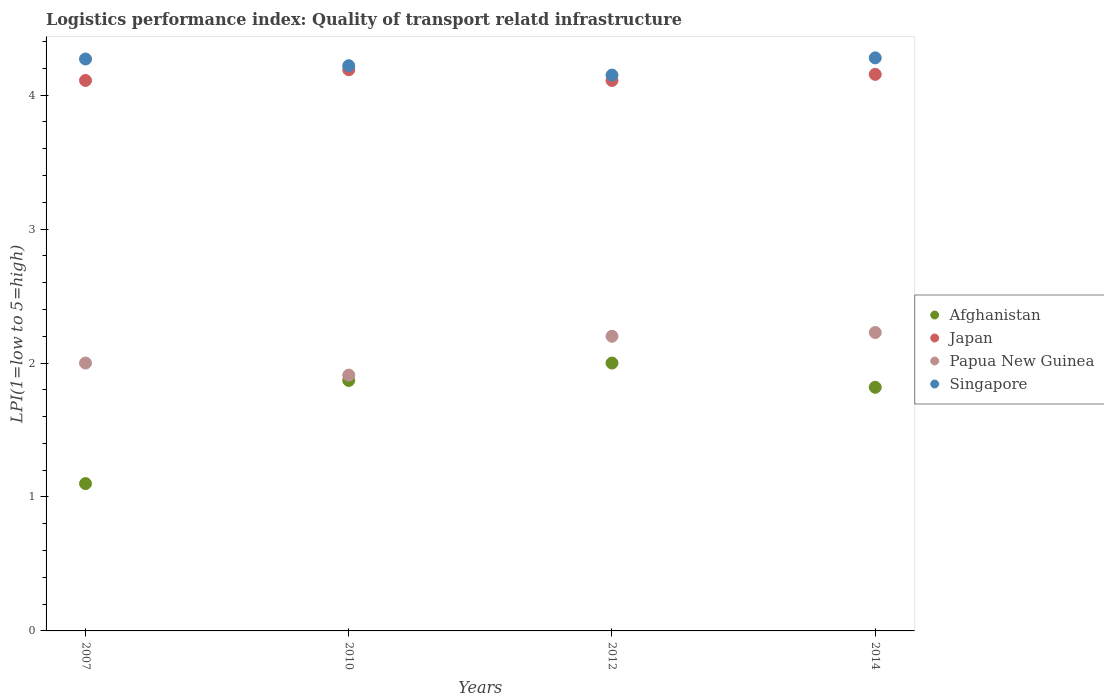How many different coloured dotlines are there?
Provide a short and direct response. 4. Is the number of dotlines equal to the number of legend labels?
Provide a succinct answer. Yes. What is the logistics performance index in Afghanistan in 2010?
Keep it short and to the point. 1.87. In which year was the logistics performance index in Papua New Guinea minimum?
Give a very brief answer. 2010. What is the total logistics performance index in Papua New Guinea in the graph?
Provide a short and direct response. 8.34. What is the difference between the logistics performance index in Papua New Guinea in 2010 and that in 2012?
Your response must be concise. -0.29. What is the difference between the logistics performance index in Singapore in 2007 and the logistics performance index in Afghanistan in 2010?
Offer a terse response. 2.4. What is the average logistics performance index in Afghanistan per year?
Give a very brief answer. 1.7. In the year 2012, what is the difference between the logistics performance index in Singapore and logistics performance index in Afghanistan?
Offer a terse response. 2.15. What is the ratio of the logistics performance index in Papua New Guinea in 2007 to that in 2014?
Keep it short and to the point. 0.9. Is the logistics performance index in Papua New Guinea in 2007 less than that in 2014?
Keep it short and to the point. Yes. Is the difference between the logistics performance index in Singapore in 2007 and 2012 greater than the difference between the logistics performance index in Afghanistan in 2007 and 2012?
Ensure brevity in your answer.  Yes. What is the difference between the highest and the second highest logistics performance index in Papua New Guinea?
Make the answer very short. 0.03. What is the difference between the highest and the lowest logistics performance index in Singapore?
Make the answer very short. 0.13. Is the sum of the logistics performance index in Singapore in 2010 and 2012 greater than the maximum logistics performance index in Afghanistan across all years?
Provide a succinct answer. Yes. Is it the case that in every year, the sum of the logistics performance index in Japan and logistics performance index in Singapore  is greater than the logistics performance index in Papua New Guinea?
Ensure brevity in your answer.  Yes. Is the logistics performance index in Afghanistan strictly greater than the logistics performance index in Singapore over the years?
Provide a short and direct response. No. Is the logistics performance index in Papua New Guinea strictly less than the logistics performance index in Japan over the years?
Give a very brief answer. Yes. How many dotlines are there?
Offer a very short reply. 4. How many years are there in the graph?
Make the answer very short. 4. What is the difference between two consecutive major ticks on the Y-axis?
Provide a short and direct response. 1. Does the graph contain grids?
Provide a short and direct response. No. What is the title of the graph?
Give a very brief answer. Logistics performance index: Quality of transport relatd infrastructure. Does "Montenegro" appear as one of the legend labels in the graph?
Offer a terse response. No. What is the label or title of the X-axis?
Your response must be concise. Years. What is the label or title of the Y-axis?
Ensure brevity in your answer.  LPI(1=low to 5=high). What is the LPI(1=low to 5=high) of Afghanistan in 2007?
Offer a very short reply. 1.1. What is the LPI(1=low to 5=high) in Japan in 2007?
Make the answer very short. 4.11. What is the LPI(1=low to 5=high) in Papua New Guinea in 2007?
Offer a very short reply. 2. What is the LPI(1=low to 5=high) in Singapore in 2007?
Keep it short and to the point. 4.27. What is the LPI(1=low to 5=high) in Afghanistan in 2010?
Ensure brevity in your answer.  1.87. What is the LPI(1=low to 5=high) in Japan in 2010?
Keep it short and to the point. 4.19. What is the LPI(1=low to 5=high) in Papua New Guinea in 2010?
Your response must be concise. 1.91. What is the LPI(1=low to 5=high) of Singapore in 2010?
Ensure brevity in your answer.  4.22. What is the LPI(1=low to 5=high) in Afghanistan in 2012?
Offer a terse response. 2. What is the LPI(1=low to 5=high) of Japan in 2012?
Offer a very short reply. 4.11. What is the LPI(1=low to 5=high) of Papua New Guinea in 2012?
Your answer should be compact. 2.2. What is the LPI(1=low to 5=high) in Singapore in 2012?
Your response must be concise. 4.15. What is the LPI(1=low to 5=high) of Afghanistan in 2014?
Provide a succinct answer. 1.82. What is the LPI(1=low to 5=high) of Japan in 2014?
Offer a terse response. 4.16. What is the LPI(1=low to 5=high) in Papua New Guinea in 2014?
Give a very brief answer. 2.23. What is the LPI(1=low to 5=high) of Singapore in 2014?
Your response must be concise. 4.28. Across all years, what is the maximum LPI(1=low to 5=high) of Afghanistan?
Keep it short and to the point. 2. Across all years, what is the maximum LPI(1=low to 5=high) of Japan?
Provide a short and direct response. 4.19. Across all years, what is the maximum LPI(1=low to 5=high) of Papua New Guinea?
Give a very brief answer. 2.23. Across all years, what is the maximum LPI(1=low to 5=high) of Singapore?
Keep it short and to the point. 4.28. Across all years, what is the minimum LPI(1=low to 5=high) in Japan?
Your answer should be very brief. 4.11. Across all years, what is the minimum LPI(1=low to 5=high) of Papua New Guinea?
Your answer should be compact. 1.91. Across all years, what is the minimum LPI(1=low to 5=high) in Singapore?
Make the answer very short. 4.15. What is the total LPI(1=low to 5=high) in Afghanistan in the graph?
Ensure brevity in your answer.  6.79. What is the total LPI(1=low to 5=high) in Japan in the graph?
Provide a short and direct response. 16.57. What is the total LPI(1=low to 5=high) of Papua New Guinea in the graph?
Keep it short and to the point. 8.34. What is the total LPI(1=low to 5=high) of Singapore in the graph?
Your answer should be compact. 16.92. What is the difference between the LPI(1=low to 5=high) in Afghanistan in 2007 and that in 2010?
Offer a terse response. -0.77. What is the difference between the LPI(1=low to 5=high) of Japan in 2007 and that in 2010?
Your answer should be very brief. -0.08. What is the difference between the LPI(1=low to 5=high) in Papua New Guinea in 2007 and that in 2010?
Your answer should be compact. 0.09. What is the difference between the LPI(1=low to 5=high) in Singapore in 2007 and that in 2010?
Your answer should be very brief. 0.05. What is the difference between the LPI(1=low to 5=high) of Afghanistan in 2007 and that in 2012?
Keep it short and to the point. -0.9. What is the difference between the LPI(1=low to 5=high) of Japan in 2007 and that in 2012?
Provide a short and direct response. 0. What is the difference between the LPI(1=low to 5=high) of Singapore in 2007 and that in 2012?
Offer a very short reply. 0.12. What is the difference between the LPI(1=low to 5=high) in Afghanistan in 2007 and that in 2014?
Keep it short and to the point. -0.72. What is the difference between the LPI(1=low to 5=high) of Japan in 2007 and that in 2014?
Make the answer very short. -0.05. What is the difference between the LPI(1=low to 5=high) in Papua New Guinea in 2007 and that in 2014?
Provide a succinct answer. -0.23. What is the difference between the LPI(1=low to 5=high) of Singapore in 2007 and that in 2014?
Ensure brevity in your answer.  -0.01. What is the difference between the LPI(1=low to 5=high) of Afghanistan in 2010 and that in 2012?
Give a very brief answer. -0.13. What is the difference between the LPI(1=low to 5=high) of Papua New Guinea in 2010 and that in 2012?
Your answer should be compact. -0.29. What is the difference between the LPI(1=low to 5=high) of Singapore in 2010 and that in 2012?
Keep it short and to the point. 0.07. What is the difference between the LPI(1=low to 5=high) of Afghanistan in 2010 and that in 2014?
Your response must be concise. 0.05. What is the difference between the LPI(1=low to 5=high) in Japan in 2010 and that in 2014?
Your answer should be very brief. 0.03. What is the difference between the LPI(1=low to 5=high) in Papua New Guinea in 2010 and that in 2014?
Keep it short and to the point. -0.32. What is the difference between the LPI(1=low to 5=high) of Singapore in 2010 and that in 2014?
Offer a very short reply. -0.06. What is the difference between the LPI(1=low to 5=high) of Afghanistan in 2012 and that in 2014?
Your answer should be very brief. 0.18. What is the difference between the LPI(1=low to 5=high) of Japan in 2012 and that in 2014?
Keep it short and to the point. -0.05. What is the difference between the LPI(1=low to 5=high) in Papua New Guinea in 2012 and that in 2014?
Provide a short and direct response. -0.03. What is the difference between the LPI(1=low to 5=high) in Singapore in 2012 and that in 2014?
Give a very brief answer. -0.13. What is the difference between the LPI(1=low to 5=high) of Afghanistan in 2007 and the LPI(1=low to 5=high) of Japan in 2010?
Offer a very short reply. -3.09. What is the difference between the LPI(1=low to 5=high) of Afghanistan in 2007 and the LPI(1=low to 5=high) of Papua New Guinea in 2010?
Provide a succinct answer. -0.81. What is the difference between the LPI(1=low to 5=high) in Afghanistan in 2007 and the LPI(1=low to 5=high) in Singapore in 2010?
Ensure brevity in your answer.  -3.12. What is the difference between the LPI(1=low to 5=high) of Japan in 2007 and the LPI(1=low to 5=high) of Papua New Guinea in 2010?
Your answer should be very brief. 2.2. What is the difference between the LPI(1=low to 5=high) of Japan in 2007 and the LPI(1=low to 5=high) of Singapore in 2010?
Your response must be concise. -0.11. What is the difference between the LPI(1=low to 5=high) in Papua New Guinea in 2007 and the LPI(1=low to 5=high) in Singapore in 2010?
Your response must be concise. -2.22. What is the difference between the LPI(1=low to 5=high) of Afghanistan in 2007 and the LPI(1=low to 5=high) of Japan in 2012?
Provide a succinct answer. -3.01. What is the difference between the LPI(1=low to 5=high) of Afghanistan in 2007 and the LPI(1=low to 5=high) of Singapore in 2012?
Keep it short and to the point. -3.05. What is the difference between the LPI(1=low to 5=high) in Japan in 2007 and the LPI(1=low to 5=high) in Papua New Guinea in 2012?
Offer a very short reply. 1.91. What is the difference between the LPI(1=low to 5=high) of Japan in 2007 and the LPI(1=low to 5=high) of Singapore in 2012?
Your response must be concise. -0.04. What is the difference between the LPI(1=low to 5=high) of Papua New Guinea in 2007 and the LPI(1=low to 5=high) of Singapore in 2012?
Ensure brevity in your answer.  -2.15. What is the difference between the LPI(1=low to 5=high) of Afghanistan in 2007 and the LPI(1=low to 5=high) of Japan in 2014?
Your answer should be compact. -3.06. What is the difference between the LPI(1=low to 5=high) in Afghanistan in 2007 and the LPI(1=low to 5=high) in Papua New Guinea in 2014?
Provide a succinct answer. -1.13. What is the difference between the LPI(1=low to 5=high) of Afghanistan in 2007 and the LPI(1=low to 5=high) of Singapore in 2014?
Provide a short and direct response. -3.18. What is the difference between the LPI(1=low to 5=high) of Japan in 2007 and the LPI(1=low to 5=high) of Papua New Guinea in 2014?
Your response must be concise. 1.88. What is the difference between the LPI(1=low to 5=high) in Japan in 2007 and the LPI(1=low to 5=high) in Singapore in 2014?
Make the answer very short. -0.17. What is the difference between the LPI(1=low to 5=high) in Papua New Guinea in 2007 and the LPI(1=low to 5=high) in Singapore in 2014?
Your answer should be compact. -2.28. What is the difference between the LPI(1=low to 5=high) of Afghanistan in 2010 and the LPI(1=low to 5=high) of Japan in 2012?
Ensure brevity in your answer.  -2.24. What is the difference between the LPI(1=low to 5=high) in Afghanistan in 2010 and the LPI(1=low to 5=high) in Papua New Guinea in 2012?
Provide a short and direct response. -0.33. What is the difference between the LPI(1=low to 5=high) in Afghanistan in 2010 and the LPI(1=low to 5=high) in Singapore in 2012?
Give a very brief answer. -2.28. What is the difference between the LPI(1=low to 5=high) in Japan in 2010 and the LPI(1=low to 5=high) in Papua New Guinea in 2012?
Your answer should be compact. 1.99. What is the difference between the LPI(1=low to 5=high) of Papua New Guinea in 2010 and the LPI(1=low to 5=high) of Singapore in 2012?
Provide a succinct answer. -2.24. What is the difference between the LPI(1=low to 5=high) of Afghanistan in 2010 and the LPI(1=low to 5=high) of Japan in 2014?
Your answer should be compact. -2.29. What is the difference between the LPI(1=low to 5=high) in Afghanistan in 2010 and the LPI(1=low to 5=high) in Papua New Guinea in 2014?
Keep it short and to the point. -0.36. What is the difference between the LPI(1=low to 5=high) of Afghanistan in 2010 and the LPI(1=low to 5=high) of Singapore in 2014?
Provide a succinct answer. -2.41. What is the difference between the LPI(1=low to 5=high) in Japan in 2010 and the LPI(1=low to 5=high) in Papua New Guinea in 2014?
Keep it short and to the point. 1.96. What is the difference between the LPI(1=low to 5=high) of Japan in 2010 and the LPI(1=low to 5=high) of Singapore in 2014?
Provide a succinct answer. -0.09. What is the difference between the LPI(1=low to 5=high) of Papua New Guinea in 2010 and the LPI(1=low to 5=high) of Singapore in 2014?
Offer a very short reply. -2.37. What is the difference between the LPI(1=low to 5=high) in Afghanistan in 2012 and the LPI(1=low to 5=high) in Japan in 2014?
Provide a short and direct response. -2.16. What is the difference between the LPI(1=low to 5=high) of Afghanistan in 2012 and the LPI(1=low to 5=high) of Papua New Guinea in 2014?
Give a very brief answer. -0.23. What is the difference between the LPI(1=low to 5=high) of Afghanistan in 2012 and the LPI(1=low to 5=high) of Singapore in 2014?
Make the answer very short. -2.28. What is the difference between the LPI(1=low to 5=high) in Japan in 2012 and the LPI(1=low to 5=high) in Papua New Guinea in 2014?
Keep it short and to the point. 1.88. What is the difference between the LPI(1=low to 5=high) of Japan in 2012 and the LPI(1=low to 5=high) of Singapore in 2014?
Give a very brief answer. -0.17. What is the difference between the LPI(1=low to 5=high) of Papua New Guinea in 2012 and the LPI(1=low to 5=high) of Singapore in 2014?
Offer a very short reply. -2.08. What is the average LPI(1=low to 5=high) of Afghanistan per year?
Provide a short and direct response. 1.7. What is the average LPI(1=low to 5=high) in Japan per year?
Make the answer very short. 4.14. What is the average LPI(1=low to 5=high) in Papua New Guinea per year?
Provide a succinct answer. 2.08. What is the average LPI(1=low to 5=high) in Singapore per year?
Provide a succinct answer. 4.23. In the year 2007, what is the difference between the LPI(1=low to 5=high) in Afghanistan and LPI(1=low to 5=high) in Japan?
Make the answer very short. -3.01. In the year 2007, what is the difference between the LPI(1=low to 5=high) of Afghanistan and LPI(1=low to 5=high) of Papua New Guinea?
Ensure brevity in your answer.  -0.9. In the year 2007, what is the difference between the LPI(1=low to 5=high) of Afghanistan and LPI(1=low to 5=high) of Singapore?
Your answer should be very brief. -3.17. In the year 2007, what is the difference between the LPI(1=low to 5=high) of Japan and LPI(1=low to 5=high) of Papua New Guinea?
Offer a very short reply. 2.11. In the year 2007, what is the difference between the LPI(1=low to 5=high) of Japan and LPI(1=low to 5=high) of Singapore?
Offer a very short reply. -0.16. In the year 2007, what is the difference between the LPI(1=low to 5=high) in Papua New Guinea and LPI(1=low to 5=high) in Singapore?
Keep it short and to the point. -2.27. In the year 2010, what is the difference between the LPI(1=low to 5=high) of Afghanistan and LPI(1=low to 5=high) of Japan?
Your answer should be compact. -2.32. In the year 2010, what is the difference between the LPI(1=low to 5=high) in Afghanistan and LPI(1=low to 5=high) in Papua New Guinea?
Offer a very short reply. -0.04. In the year 2010, what is the difference between the LPI(1=low to 5=high) in Afghanistan and LPI(1=low to 5=high) in Singapore?
Provide a succinct answer. -2.35. In the year 2010, what is the difference between the LPI(1=low to 5=high) of Japan and LPI(1=low to 5=high) of Papua New Guinea?
Make the answer very short. 2.28. In the year 2010, what is the difference between the LPI(1=low to 5=high) of Japan and LPI(1=low to 5=high) of Singapore?
Make the answer very short. -0.03. In the year 2010, what is the difference between the LPI(1=low to 5=high) in Papua New Guinea and LPI(1=low to 5=high) in Singapore?
Offer a very short reply. -2.31. In the year 2012, what is the difference between the LPI(1=low to 5=high) in Afghanistan and LPI(1=low to 5=high) in Japan?
Make the answer very short. -2.11. In the year 2012, what is the difference between the LPI(1=low to 5=high) in Afghanistan and LPI(1=low to 5=high) in Papua New Guinea?
Make the answer very short. -0.2. In the year 2012, what is the difference between the LPI(1=low to 5=high) in Afghanistan and LPI(1=low to 5=high) in Singapore?
Your response must be concise. -2.15. In the year 2012, what is the difference between the LPI(1=low to 5=high) in Japan and LPI(1=low to 5=high) in Papua New Guinea?
Your answer should be compact. 1.91. In the year 2012, what is the difference between the LPI(1=low to 5=high) of Japan and LPI(1=low to 5=high) of Singapore?
Give a very brief answer. -0.04. In the year 2012, what is the difference between the LPI(1=low to 5=high) in Papua New Guinea and LPI(1=low to 5=high) in Singapore?
Your response must be concise. -1.95. In the year 2014, what is the difference between the LPI(1=low to 5=high) in Afghanistan and LPI(1=low to 5=high) in Japan?
Keep it short and to the point. -2.34. In the year 2014, what is the difference between the LPI(1=low to 5=high) of Afghanistan and LPI(1=low to 5=high) of Papua New Guinea?
Give a very brief answer. -0.41. In the year 2014, what is the difference between the LPI(1=low to 5=high) in Afghanistan and LPI(1=low to 5=high) in Singapore?
Give a very brief answer. -2.46. In the year 2014, what is the difference between the LPI(1=low to 5=high) of Japan and LPI(1=low to 5=high) of Papua New Guinea?
Your response must be concise. 1.93. In the year 2014, what is the difference between the LPI(1=low to 5=high) of Japan and LPI(1=low to 5=high) of Singapore?
Provide a succinct answer. -0.12. In the year 2014, what is the difference between the LPI(1=low to 5=high) of Papua New Guinea and LPI(1=low to 5=high) of Singapore?
Provide a succinct answer. -2.05. What is the ratio of the LPI(1=low to 5=high) of Afghanistan in 2007 to that in 2010?
Your response must be concise. 0.59. What is the ratio of the LPI(1=low to 5=high) of Japan in 2007 to that in 2010?
Make the answer very short. 0.98. What is the ratio of the LPI(1=low to 5=high) in Papua New Guinea in 2007 to that in 2010?
Provide a short and direct response. 1.05. What is the ratio of the LPI(1=low to 5=high) in Singapore in 2007 to that in 2010?
Provide a short and direct response. 1.01. What is the ratio of the LPI(1=low to 5=high) of Afghanistan in 2007 to that in 2012?
Your answer should be compact. 0.55. What is the ratio of the LPI(1=low to 5=high) in Papua New Guinea in 2007 to that in 2012?
Keep it short and to the point. 0.91. What is the ratio of the LPI(1=low to 5=high) of Singapore in 2007 to that in 2012?
Offer a very short reply. 1.03. What is the ratio of the LPI(1=low to 5=high) in Afghanistan in 2007 to that in 2014?
Offer a terse response. 0.6. What is the ratio of the LPI(1=low to 5=high) of Japan in 2007 to that in 2014?
Offer a very short reply. 0.99. What is the ratio of the LPI(1=low to 5=high) in Papua New Guinea in 2007 to that in 2014?
Keep it short and to the point. 0.9. What is the ratio of the LPI(1=low to 5=high) of Afghanistan in 2010 to that in 2012?
Ensure brevity in your answer.  0.94. What is the ratio of the LPI(1=low to 5=high) in Japan in 2010 to that in 2012?
Keep it short and to the point. 1.02. What is the ratio of the LPI(1=low to 5=high) of Papua New Guinea in 2010 to that in 2012?
Ensure brevity in your answer.  0.87. What is the ratio of the LPI(1=low to 5=high) of Singapore in 2010 to that in 2012?
Ensure brevity in your answer.  1.02. What is the ratio of the LPI(1=low to 5=high) of Afghanistan in 2010 to that in 2014?
Ensure brevity in your answer.  1.03. What is the ratio of the LPI(1=low to 5=high) of Japan in 2010 to that in 2014?
Keep it short and to the point. 1.01. What is the ratio of the LPI(1=low to 5=high) of Papua New Guinea in 2010 to that in 2014?
Give a very brief answer. 0.86. What is the ratio of the LPI(1=low to 5=high) of Singapore in 2010 to that in 2014?
Provide a succinct answer. 0.99. What is the ratio of the LPI(1=low to 5=high) in Afghanistan in 2012 to that in 2014?
Offer a terse response. 1.1. What is the ratio of the LPI(1=low to 5=high) in Japan in 2012 to that in 2014?
Make the answer very short. 0.99. What is the ratio of the LPI(1=low to 5=high) in Papua New Guinea in 2012 to that in 2014?
Offer a terse response. 0.99. What is the ratio of the LPI(1=low to 5=high) in Singapore in 2012 to that in 2014?
Offer a very short reply. 0.97. What is the difference between the highest and the second highest LPI(1=low to 5=high) in Afghanistan?
Your response must be concise. 0.13. What is the difference between the highest and the second highest LPI(1=low to 5=high) of Japan?
Give a very brief answer. 0.03. What is the difference between the highest and the second highest LPI(1=low to 5=high) in Papua New Guinea?
Provide a succinct answer. 0.03. What is the difference between the highest and the second highest LPI(1=low to 5=high) in Singapore?
Give a very brief answer. 0.01. What is the difference between the highest and the lowest LPI(1=low to 5=high) of Afghanistan?
Provide a succinct answer. 0.9. What is the difference between the highest and the lowest LPI(1=low to 5=high) of Papua New Guinea?
Give a very brief answer. 0.32. What is the difference between the highest and the lowest LPI(1=low to 5=high) in Singapore?
Your answer should be very brief. 0.13. 